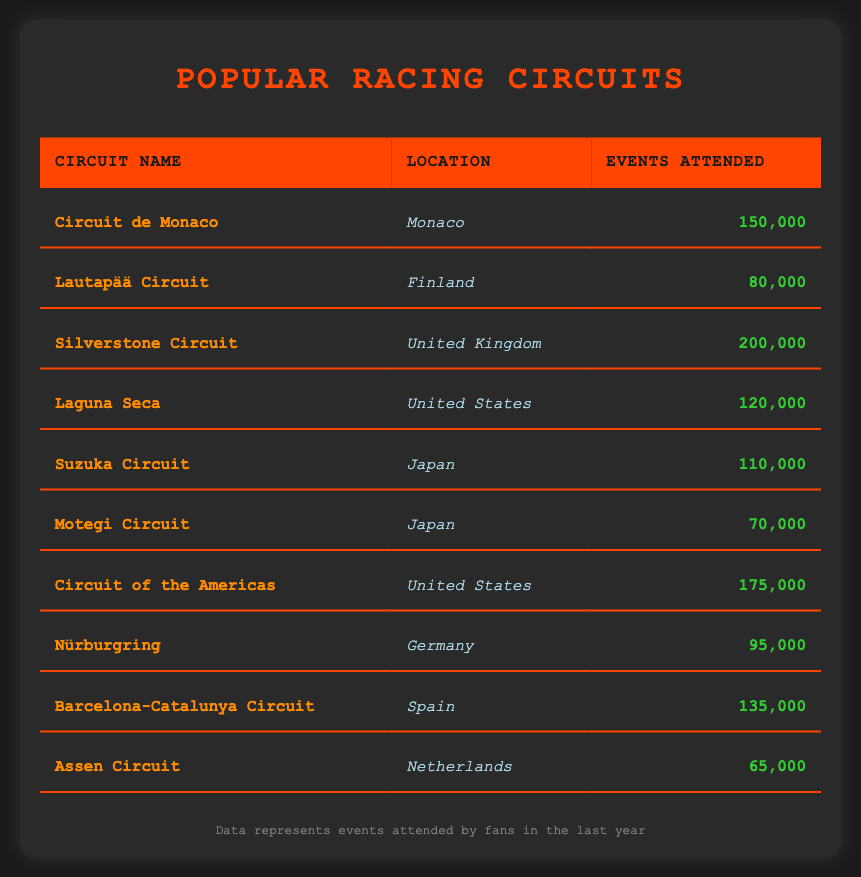What is the circuit with the highest events attended? Looking at the "events attended" column, Silverstone Circuit has the highest value of 200,000 events attended.
Answer: Silverstone Circuit How many events were attended at the Circuit de Monaco? The table shows that there were 150,000 events attended at the Circuit de Monaco.
Answer: 150,000 What is the total number of events attended for circuits located in the United States? Adding the events for Circuit of the Americas (175,000) and Laguna Seca (120,000), the total is 175,000 + 120,000 = 295,000.
Answer: 295,000 Which circuit had fewer than 100,000 events attended? The circuits with fewer than 100,000 events attended are the Motegi Circuit (70,000) and Assen Circuit (65,000).
Answer: Motegi Circuit and Assen Circuit Is the Nürburgring located in Germany? The table indicates that the Nürburgring is indeed located in Germany.
Answer: Yes What is the average number of events attended for circuits in Japan? The events attended for Suzuka Circuit is 110,000 and for Motegi Circuit is 70,000. The average is (110,000 + 70,000) / 2 = 90,000.
Answer: 90,000 Which circuit had more events attended: Lautapää Circuit or Assen Circuit? Lautapää Circuit had 80,000 events while Assen Circuit had 65,000 events. Comparing the two, Lautapää Circuit had more events attended.
Answer: Lautapää Circuit What is the difference in events attended between the Circuit of the Americas and the Silverstone Circuit? The Circuit of the Americas had 175,000 events attended, and Silverstone Circuit had 200,000. The difference is 200,000 - 175,000 = 25,000.
Answer: 25,000 How many circuits had more than 100,000 events attended? The circuits with more than 100,000 events attended are Silverstone Circuit, Circuit of the Americas, Circuit de Monaco, Laguna Seca, Suzuka Circuit, and Barcelona-Catalunya Circuit. That's a total of 6 circuits.
Answer: 6 